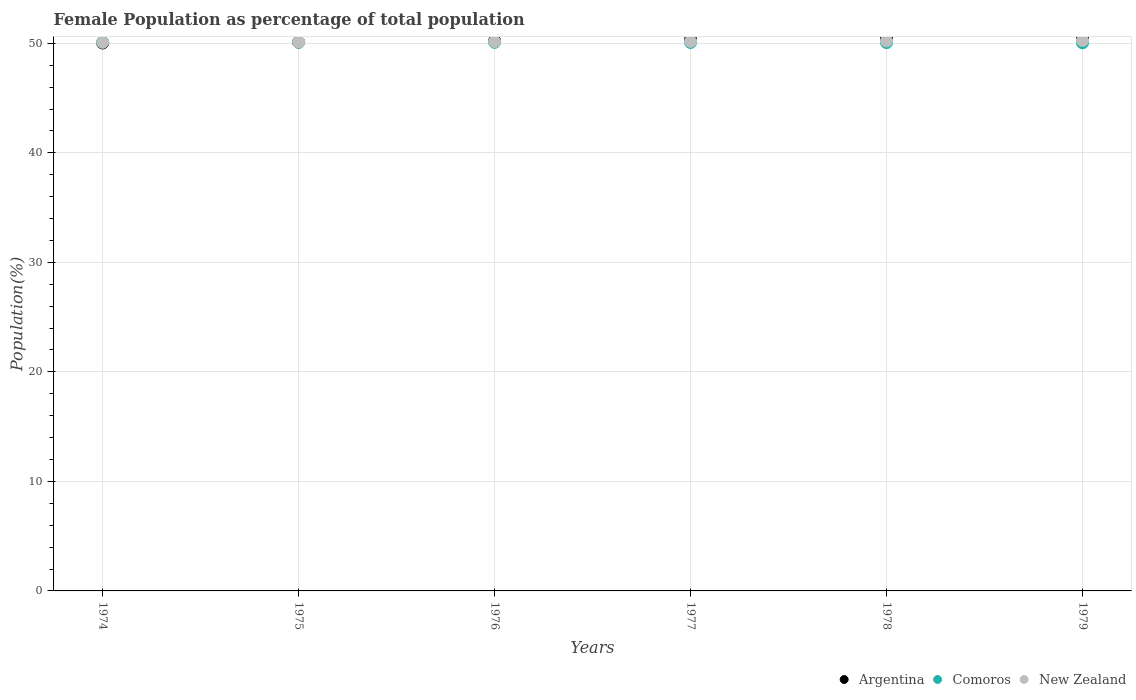Is the number of dotlines equal to the number of legend labels?
Your response must be concise. Yes. What is the female population in in Argentina in 1977?
Your answer should be very brief. 50.34. Across all years, what is the maximum female population in in Comoros?
Make the answer very short. 50.11. Across all years, what is the minimum female population in in Comoros?
Keep it short and to the point. 50.05. In which year was the female population in in Comoros maximum?
Your response must be concise. 1974. In which year was the female population in in New Zealand minimum?
Give a very brief answer. 1974. What is the total female population in in Comoros in the graph?
Provide a short and direct response. 300.5. What is the difference between the female population in in New Zealand in 1975 and that in 1978?
Give a very brief answer. -0.1. What is the difference between the female population in in Comoros in 1975 and the female population in in Argentina in 1976?
Offer a terse response. -0.12. What is the average female population in in New Zealand per year?
Offer a terse response. 50.17. In the year 1979, what is the difference between the female population in in New Zealand and female population in in Argentina?
Offer a very short reply. -0.33. What is the ratio of the female population in in Argentina in 1975 to that in 1979?
Keep it short and to the point. 0.99. Is the female population in in New Zealand in 1974 less than that in 1979?
Keep it short and to the point. Yes. What is the difference between the highest and the second highest female population in in Argentina?
Provide a succinct answer. 0.12. What is the difference between the highest and the lowest female population in in Argentina?
Your response must be concise. 0.56. In how many years, is the female population in in New Zealand greater than the average female population in in New Zealand taken over all years?
Offer a terse response. 3. Is it the case that in every year, the sum of the female population in in New Zealand and female population in in Argentina  is greater than the female population in in Comoros?
Your answer should be compact. Yes. Does the female population in in Comoros monotonically increase over the years?
Offer a terse response. No. Is the female population in in New Zealand strictly less than the female population in in Argentina over the years?
Provide a succinct answer. No. Does the graph contain any zero values?
Provide a short and direct response. No. How many legend labels are there?
Your answer should be compact. 3. What is the title of the graph?
Offer a terse response. Female Population as percentage of total population. Does "Lesotho" appear as one of the legend labels in the graph?
Make the answer very short. No. What is the label or title of the Y-axis?
Provide a succinct answer. Population(%). What is the Population(%) in Argentina in 1974?
Offer a terse response. 50.03. What is the Population(%) in Comoros in 1974?
Your answer should be very brief. 50.11. What is the Population(%) of New Zealand in 1974?
Ensure brevity in your answer.  50.1. What is the Population(%) of Argentina in 1975?
Keep it short and to the point. 50.11. What is the Population(%) in Comoros in 1975?
Your answer should be compact. 50.1. What is the Population(%) of New Zealand in 1975?
Provide a succinct answer. 50.12. What is the Population(%) in Argentina in 1976?
Offer a very short reply. 50.22. What is the Population(%) in Comoros in 1976?
Your response must be concise. 50.09. What is the Population(%) in New Zealand in 1976?
Your response must be concise. 50.15. What is the Population(%) of Argentina in 1977?
Give a very brief answer. 50.34. What is the Population(%) of Comoros in 1977?
Provide a short and direct response. 50.08. What is the Population(%) of New Zealand in 1977?
Your answer should be compact. 50.18. What is the Population(%) of Argentina in 1978?
Ensure brevity in your answer.  50.48. What is the Population(%) in Comoros in 1978?
Provide a succinct answer. 50.07. What is the Population(%) in New Zealand in 1978?
Give a very brief answer. 50.22. What is the Population(%) of Argentina in 1979?
Your answer should be compact. 50.59. What is the Population(%) in Comoros in 1979?
Offer a terse response. 50.05. What is the Population(%) of New Zealand in 1979?
Make the answer very short. 50.26. Across all years, what is the maximum Population(%) in Argentina?
Make the answer very short. 50.59. Across all years, what is the maximum Population(%) of Comoros?
Keep it short and to the point. 50.11. Across all years, what is the maximum Population(%) in New Zealand?
Provide a succinct answer. 50.26. Across all years, what is the minimum Population(%) in Argentina?
Your answer should be compact. 50.03. Across all years, what is the minimum Population(%) in Comoros?
Ensure brevity in your answer.  50.05. Across all years, what is the minimum Population(%) in New Zealand?
Your answer should be very brief. 50.1. What is the total Population(%) in Argentina in the graph?
Your response must be concise. 301.78. What is the total Population(%) in Comoros in the graph?
Your answer should be very brief. 300.5. What is the total Population(%) of New Zealand in the graph?
Keep it short and to the point. 301.04. What is the difference between the Population(%) of Argentina in 1974 and that in 1975?
Offer a terse response. -0.08. What is the difference between the Population(%) of Comoros in 1974 and that in 1975?
Your answer should be compact. 0.01. What is the difference between the Population(%) in New Zealand in 1974 and that in 1975?
Offer a very short reply. -0.02. What is the difference between the Population(%) in Argentina in 1974 and that in 1976?
Your response must be concise. -0.18. What is the difference between the Population(%) in Comoros in 1974 and that in 1976?
Give a very brief answer. 0.02. What is the difference between the Population(%) of New Zealand in 1974 and that in 1976?
Provide a succinct answer. -0.05. What is the difference between the Population(%) in Argentina in 1974 and that in 1977?
Offer a very short reply. -0.31. What is the difference between the Population(%) in Comoros in 1974 and that in 1977?
Your answer should be compact. 0.03. What is the difference between the Population(%) in New Zealand in 1974 and that in 1977?
Ensure brevity in your answer.  -0.08. What is the difference between the Population(%) in Argentina in 1974 and that in 1978?
Provide a succinct answer. -0.44. What is the difference between the Population(%) of Comoros in 1974 and that in 1978?
Offer a terse response. 0.05. What is the difference between the Population(%) of New Zealand in 1974 and that in 1978?
Offer a very short reply. -0.12. What is the difference between the Population(%) in Argentina in 1974 and that in 1979?
Make the answer very short. -0.56. What is the difference between the Population(%) of Comoros in 1974 and that in 1979?
Your answer should be very brief. 0.06. What is the difference between the Population(%) of New Zealand in 1974 and that in 1979?
Provide a short and direct response. -0.16. What is the difference between the Population(%) in Argentina in 1975 and that in 1976?
Provide a short and direct response. -0.11. What is the difference between the Population(%) in Comoros in 1975 and that in 1976?
Provide a succinct answer. 0.01. What is the difference between the Population(%) in New Zealand in 1975 and that in 1976?
Offer a terse response. -0.03. What is the difference between the Population(%) of Argentina in 1975 and that in 1977?
Your answer should be compact. -0.23. What is the difference between the Population(%) in Comoros in 1975 and that in 1977?
Provide a short and direct response. 0.02. What is the difference between the Population(%) in New Zealand in 1975 and that in 1977?
Make the answer very short. -0.06. What is the difference between the Population(%) in Argentina in 1975 and that in 1978?
Your answer should be compact. -0.36. What is the difference between the Population(%) of Comoros in 1975 and that in 1978?
Your answer should be very brief. 0.04. What is the difference between the Population(%) of New Zealand in 1975 and that in 1978?
Make the answer very short. -0.1. What is the difference between the Population(%) of Argentina in 1975 and that in 1979?
Ensure brevity in your answer.  -0.48. What is the difference between the Population(%) in Comoros in 1975 and that in 1979?
Give a very brief answer. 0.05. What is the difference between the Population(%) of New Zealand in 1975 and that in 1979?
Your answer should be compact. -0.14. What is the difference between the Population(%) in Argentina in 1976 and that in 1977?
Offer a very short reply. -0.13. What is the difference between the Population(%) of Comoros in 1976 and that in 1977?
Offer a very short reply. 0.01. What is the difference between the Population(%) in New Zealand in 1976 and that in 1977?
Give a very brief answer. -0.03. What is the difference between the Population(%) of Argentina in 1976 and that in 1978?
Give a very brief answer. -0.26. What is the difference between the Population(%) of Comoros in 1976 and that in 1978?
Offer a very short reply. 0.03. What is the difference between the Population(%) of New Zealand in 1976 and that in 1978?
Make the answer very short. -0.07. What is the difference between the Population(%) in Argentina in 1976 and that in 1979?
Your response must be concise. -0.37. What is the difference between the Population(%) of Comoros in 1976 and that in 1979?
Give a very brief answer. 0.04. What is the difference between the Population(%) of New Zealand in 1976 and that in 1979?
Give a very brief answer. -0.11. What is the difference between the Population(%) of Argentina in 1977 and that in 1978?
Your answer should be compact. -0.13. What is the difference between the Population(%) of Comoros in 1977 and that in 1978?
Provide a succinct answer. 0.01. What is the difference between the Population(%) in New Zealand in 1977 and that in 1978?
Your response must be concise. -0.04. What is the difference between the Population(%) in Argentina in 1977 and that in 1979?
Provide a succinct answer. -0.25. What is the difference between the Population(%) in Comoros in 1977 and that in 1979?
Offer a very short reply. 0.03. What is the difference between the Population(%) in New Zealand in 1977 and that in 1979?
Provide a short and direct response. -0.08. What is the difference between the Population(%) of Argentina in 1978 and that in 1979?
Give a very brief answer. -0.12. What is the difference between the Population(%) in Comoros in 1978 and that in 1979?
Ensure brevity in your answer.  0.01. What is the difference between the Population(%) of New Zealand in 1978 and that in 1979?
Offer a very short reply. -0.04. What is the difference between the Population(%) of Argentina in 1974 and the Population(%) of Comoros in 1975?
Make the answer very short. -0.07. What is the difference between the Population(%) in Argentina in 1974 and the Population(%) in New Zealand in 1975?
Your answer should be compact. -0.09. What is the difference between the Population(%) of Comoros in 1974 and the Population(%) of New Zealand in 1975?
Provide a short and direct response. -0.01. What is the difference between the Population(%) of Argentina in 1974 and the Population(%) of Comoros in 1976?
Keep it short and to the point. -0.06. What is the difference between the Population(%) in Argentina in 1974 and the Population(%) in New Zealand in 1976?
Your answer should be very brief. -0.12. What is the difference between the Population(%) in Comoros in 1974 and the Population(%) in New Zealand in 1976?
Your response must be concise. -0.04. What is the difference between the Population(%) of Argentina in 1974 and the Population(%) of Comoros in 1977?
Keep it short and to the point. -0.04. What is the difference between the Population(%) of Argentina in 1974 and the Population(%) of New Zealand in 1977?
Your answer should be compact. -0.15. What is the difference between the Population(%) of Comoros in 1974 and the Population(%) of New Zealand in 1977?
Provide a succinct answer. -0.07. What is the difference between the Population(%) of Argentina in 1974 and the Population(%) of Comoros in 1978?
Provide a short and direct response. -0.03. What is the difference between the Population(%) of Argentina in 1974 and the Population(%) of New Zealand in 1978?
Your answer should be very brief. -0.19. What is the difference between the Population(%) of Comoros in 1974 and the Population(%) of New Zealand in 1978?
Your answer should be very brief. -0.11. What is the difference between the Population(%) in Argentina in 1974 and the Population(%) in Comoros in 1979?
Keep it short and to the point. -0.02. What is the difference between the Population(%) of Argentina in 1974 and the Population(%) of New Zealand in 1979?
Offer a very short reply. -0.23. What is the difference between the Population(%) in Comoros in 1974 and the Population(%) in New Zealand in 1979?
Your answer should be compact. -0.15. What is the difference between the Population(%) of Argentina in 1975 and the Population(%) of Comoros in 1976?
Provide a succinct answer. 0.02. What is the difference between the Population(%) of Argentina in 1975 and the Population(%) of New Zealand in 1976?
Your answer should be very brief. -0.04. What is the difference between the Population(%) of Comoros in 1975 and the Population(%) of New Zealand in 1976?
Your response must be concise. -0.05. What is the difference between the Population(%) in Argentina in 1975 and the Population(%) in Comoros in 1977?
Ensure brevity in your answer.  0.03. What is the difference between the Population(%) of Argentina in 1975 and the Population(%) of New Zealand in 1977?
Your answer should be very brief. -0.07. What is the difference between the Population(%) in Comoros in 1975 and the Population(%) in New Zealand in 1977?
Your answer should be compact. -0.08. What is the difference between the Population(%) in Argentina in 1975 and the Population(%) in Comoros in 1978?
Ensure brevity in your answer.  0.05. What is the difference between the Population(%) in Argentina in 1975 and the Population(%) in New Zealand in 1978?
Keep it short and to the point. -0.11. What is the difference between the Population(%) in Comoros in 1975 and the Population(%) in New Zealand in 1978?
Your answer should be very brief. -0.12. What is the difference between the Population(%) of Argentina in 1975 and the Population(%) of Comoros in 1979?
Provide a succinct answer. 0.06. What is the difference between the Population(%) of Argentina in 1975 and the Population(%) of New Zealand in 1979?
Offer a terse response. -0.15. What is the difference between the Population(%) in Comoros in 1975 and the Population(%) in New Zealand in 1979?
Offer a terse response. -0.16. What is the difference between the Population(%) of Argentina in 1976 and the Population(%) of Comoros in 1977?
Offer a terse response. 0.14. What is the difference between the Population(%) of Argentina in 1976 and the Population(%) of New Zealand in 1977?
Give a very brief answer. 0.03. What is the difference between the Population(%) of Comoros in 1976 and the Population(%) of New Zealand in 1977?
Make the answer very short. -0.09. What is the difference between the Population(%) in Argentina in 1976 and the Population(%) in Comoros in 1978?
Offer a terse response. 0.15. What is the difference between the Population(%) in Argentina in 1976 and the Population(%) in New Zealand in 1978?
Keep it short and to the point. -0. What is the difference between the Population(%) of Comoros in 1976 and the Population(%) of New Zealand in 1978?
Provide a short and direct response. -0.13. What is the difference between the Population(%) of Argentina in 1976 and the Population(%) of Comoros in 1979?
Your answer should be very brief. 0.17. What is the difference between the Population(%) in Argentina in 1976 and the Population(%) in New Zealand in 1979?
Ensure brevity in your answer.  -0.04. What is the difference between the Population(%) of Comoros in 1976 and the Population(%) of New Zealand in 1979?
Provide a short and direct response. -0.17. What is the difference between the Population(%) of Argentina in 1977 and the Population(%) of Comoros in 1978?
Your answer should be very brief. 0.28. What is the difference between the Population(%) of Argentina in 1977 and the Population(%) of New Zealand in 1978?
Ensure brevity in your answer.  0.12. What is the difference between the Population(%) in Comoros in 1977 and the Population(%) in New Zealand in 1978?
Provide a succinct answer. -0.14. What is the difference between the Population(%) in Argentina in 1977 and the Population(%) in Comoros in 1979?
Your answer should be very brief. 0.29. What is the difference between the Population(%) of Argentina in 1977 and the Population(%) of New Zealand in 1979?
Ensure brevity in your answer.  0.08. What is the difference between the Population(%) of Comoros in 1977 and the Population(%) of New Zealand in 1979?
Provide a succinct answer. -0.18. What is the difference between the Population(%) in Argentina in 1978 and the Population(%) in Comoros in 1979?
Provide a succinct answer. 0.42. What is the difference between the Population(%) of Argentina in 1978 and the Population(%) of New Zealand in 1979?
Offer a very short reply. 0.21. What is the difference between the Population(%) of Comoros in 1978 and the Population(%) of New Zealand in 1979?
Keep it short and to the point. -0.19. What is the average Population(%) in Argentina per year?
Keep it short and to the point. 50.3. What is the average Population(%) of Comoros per year?
Offer a terse response. 50.08. What is the average Population(%) of New Zealand per year?
Offer a very short reply. 50.17. In the year 1974, what is the difference between the Population(%) in Argentina and Population(%) in Comoros?
Offer a terse response. -0.08. In the year 1974, what is the difference between the Population(%) in Argentina and Population(%) in New Zealand?
Your answer should be compact. -0.07. In the year 1974, what is the difference between the Population(%) in Comoros and Population(%) in New Zealand?
Offer a terse response. 0.01. In the year 1975, what is the difference between the Population(%) of Argentina and Population(%) of Comoros?
Make the answer very short. 0.01. In the year 1975, what is the difference between the Population(%) of Argentina and Population(%) of New Zealand?
Keep it short and to the point. -0.01. In the year 1975, what is the difference between the Population(%) of Comoros and Population(%) of New Zealand?
Ensure brevity in your answer.  -0.02. In the year 1976, what is the difference between the Population(%) of Argentina and Population(%) of Comoros?
Keep it short and to the point. 0.13. In the year 1976, what is the difference between the Population(%) of Argentina and Population(%) of New Zealand?
Offer a very short reply. 0.07. In the year 1976, what is the difference between the Population(%) in Comoros and Population(%) in New Zealand?
Your answer should be very brief. -0.06. In the year 1977, what is the difference between the Population(%) of Argentina and Population(%) of Comoros?
Ensure brevity in your answer.  0.27. In the year 1977, what is the difference between the Population(%) of Argentina and Population(%) of New Zealand?
Ensure brevity in your answer.  0.16. In the year 1977, what is the difference between the Population(%) in Comoros and Population(%) in New Zealand?
Ensure brevity in your answer.  -0.11. In the year 1978, what is the difference between the Population(%) of Argentina and Population(%) of Comoros?
Provide a short and direct response. 0.41. In the year 1978, what is the difference between the Population(%) of Argentina and Population(%) of New Zealand?
Your answer should be compact. 0.25. In the year 1978, what is the difference between the Population(%) of Comoros and Population(%) of New Zealand?
Offer a very short reply. -0.16. In the year 1979, what is the difference between the Population(%) in Argentina and Population(%) in Comoros?
Give a very brief answer. 0.54. In the year 1979, what is the difference between the Population(%) of Argentina and Population(%) of New Zealand?
Give a very brief answer. 0.33. In the year 1979, what is the difference between the Population(%) of Comoros and Population(%) of New Zealand?
Offer a terse response. -0.21. What is the ratio of the Population(%) of Comoros in 1974 to that in 1976?
Give a very brief answer. 1. What is the ratio of the Population(%) in Comoros in 1974 to that in 1977?
Give a very brief answer. 1. What is the ratio of the Population(%) of New Zealand in 1974 to that in 1977?
Provide a short and direct response. 1. What is the ratio of the Population(%) in Argentina in 1974 to that in 1978?
Your response must be concise. 0.99. What is the ratio of the Population(%) of New Zealand in 1974 to that in 1978?
Your answer should be very brief. 1. What is the ratio of the Population(%) of Argentina in 1974 to that in 1979?
Ensure brevity in your answer.  0.99. What is the ratio of the Population(%) of Comoros in 1974 to that in 1979?
Ensure brevity in your answer.  1. What is the ratio of the Population(%) in New Zealand in 1975 to that in 1976?
Provide a short and direct response. 1. What is the ratio of the Population(%) in Comoros in 1975 to that in 1977?
Keep it short and to the point. 1. What is the ratio of the Population(%) of Argentina in 1975 to that in 1978?
Ensure brevity in your answer.  0.99. What is the ratio of the Population(%) in New Zealand in 1975 to that in 1978?
Your answer should be very brief. 1. What is the ratio of the Population(%) of Argentina in 1975 to that in 1979?
Ensure brevity in your answer.  0.99. What is the ratio of the Population(%) of Comoros in 1976 to that in 1977?
Your response must be concise. 1. What is the ratio of the Population(%) in Argentina in 1976 to that in 1978?
Ensure brevity in your answer.  0.99. What is the ratio of the Population(%) of Comoros in 1976 to that in 1978?
Make the answer very short. 1. What is the ratio of the Population(%) in Argentina in 1976 to that in 1979?
Provide a short and direct response. 0.99. What is the ratio of the Population(%) of Argentina in 1977 to that in 1978?
Your response must be concise. 1. What is the ratio of the Population(%) in Comoros in 1977 to that in 1978?
Your answer should be very brief. 1. What is the ratio of the Population(%) in Argentina in 1977 to that in 1979?
Make the answer very short. 1. What is the ratio of the Population(%) of Argentina in 1978 to that in 1979?
Offer a very short reply. 1. What is the ratio of the Population(%) in Comoros in 1978 to that in 1979?
Offer a terse response. 1. What is the difference between the highest and the second highest Population(%) in Argentina?
Your response must be concise. 0.12. What is the difference between the highest and the second highest Population(%) of Comoros?
Offer a terse response. 0.01. What is the difference between the highest and the second highest Population(%) of New Zealand?
Keep it short and to the point. 0.04. What is the difference between the highest and the lowest Population(%) of Argentina?
Keep it short and to the point. 0.56. What is the difference between the highest and the lowest Population(%) of Comoros?
Provide a succinct answer. 0.06. What is the difference between the highest and the lowest Population(%) in New Zealand?
Make the answer very short. 0.16. 